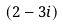Convert formula to latex. <formula><loc_0><loc_0><loc_500><loc_500>( 2 - 3 i )</formula> 